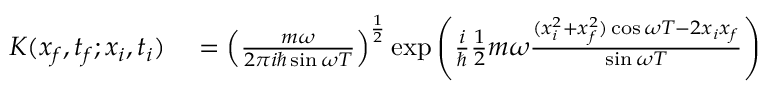Convert formula to latex. <formula><loc_0><loc_0><loc_500><loc_500>\begin{array} { r l } { K ( x _ { f } , t _ { f } ; x _ { i } , t _ { i } ) } & = \left ( { \frac { m \omega } { 2 \pi i \hbar { \sin } \omega T } } \right ) ^ { \frac { 1 } { 2 } } \exp { \left ( { \frac { i } { } } { \frac { 1 } { 2 } } m \omega { \frac { ( x _ { i } ^ { 2 } + x _ { f } ^ { 2 } ) \cos \omega T - 2 x _ { i } x _ { f } } { \sin \omega T } } \right ) } } \end{array}</formula> 